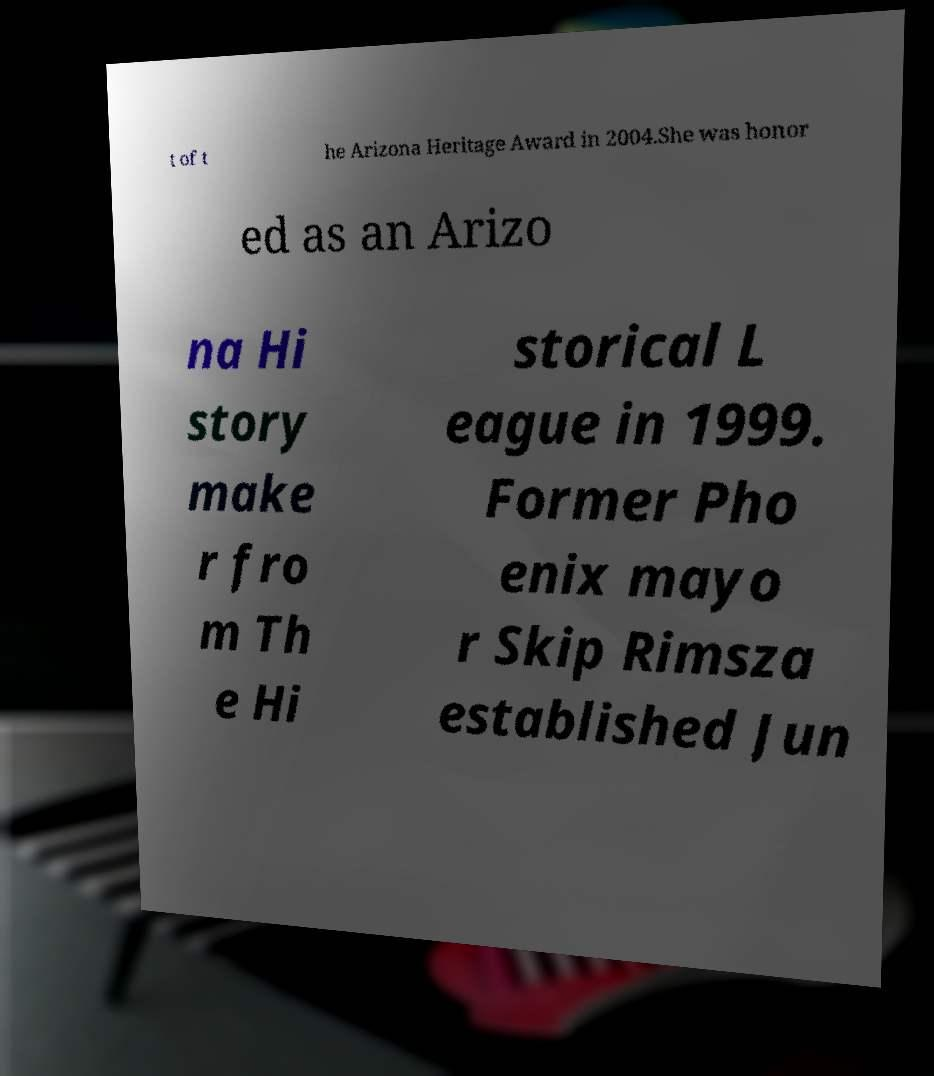Can you read and provide the text displayed in the image?This photo seems to have some interesting text. Can you extract and type it out for me? t of t he Arizona Heritage Award in 2004.She was honor ed as an Arizo na Hi story make r fro m Th e Hi storical L eague in 1999. Former Pho enix mayo r Skip Rimsza established Jun 